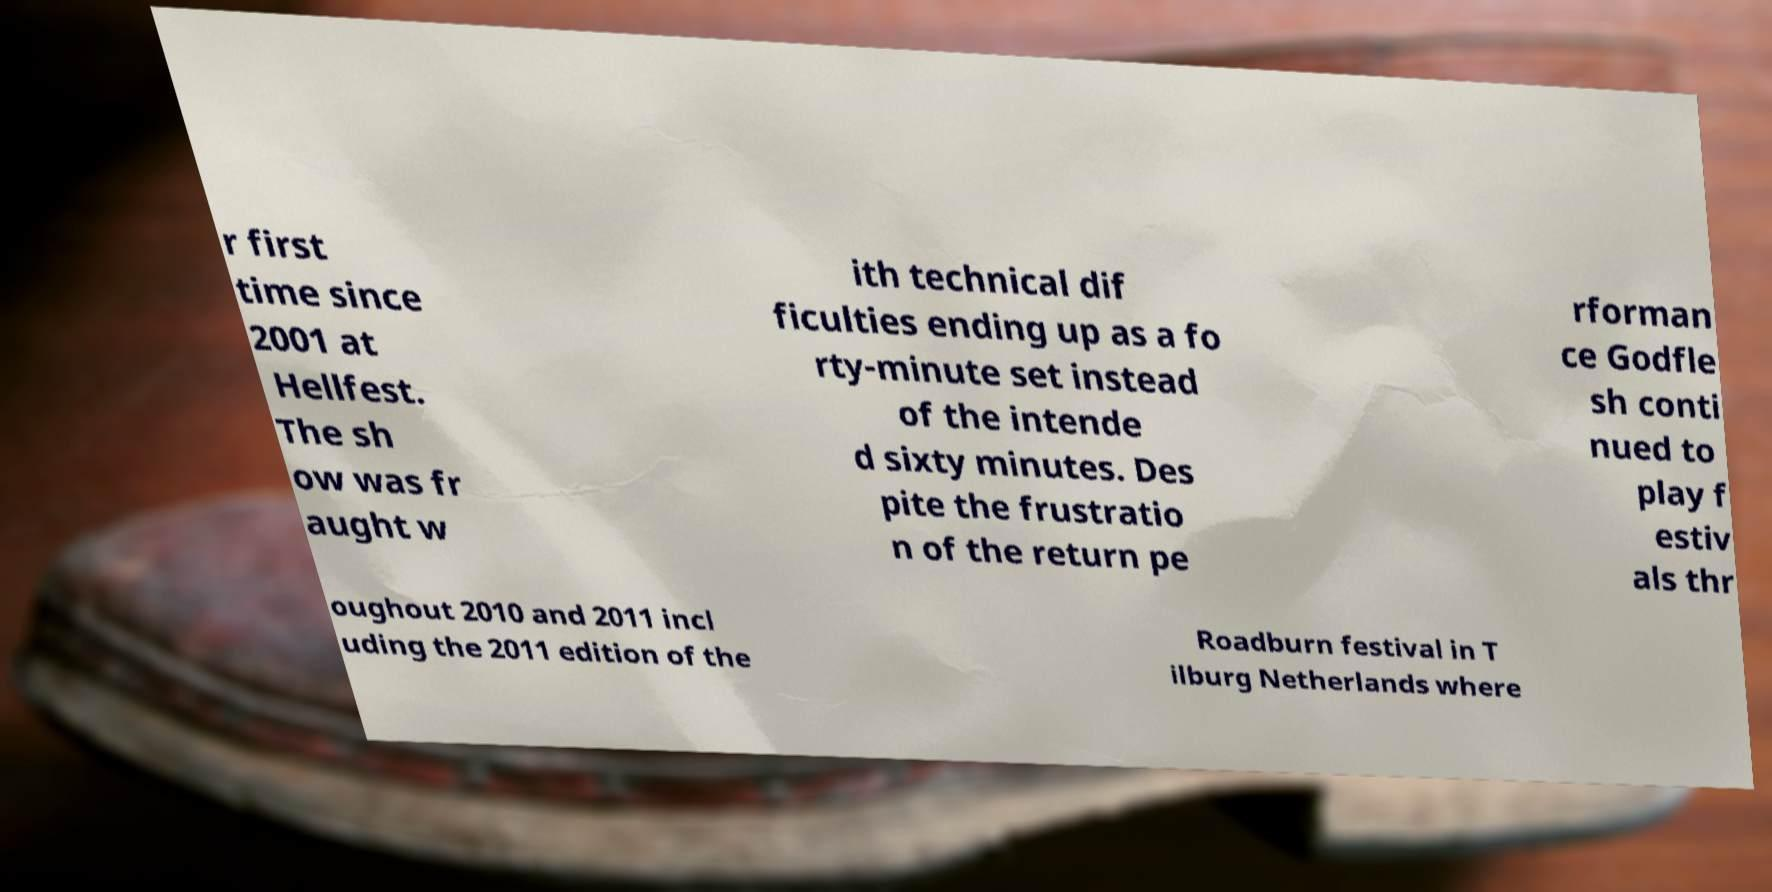Could you extract and type out the text from this image? r first time since 2001 at Hellfest. The sh ow was fr aught w ith technical dif ficulties ending up as a fo rty-minute set instead of the intende d sixty minutes. Des pite the frustratio n of the return pe rforman ce Godfle sh conti nued to play f estiv als thr oughout 2010 and 2011 incl uding the 2011 edition of the Roadburn festival in T ilburg Netherlands where 